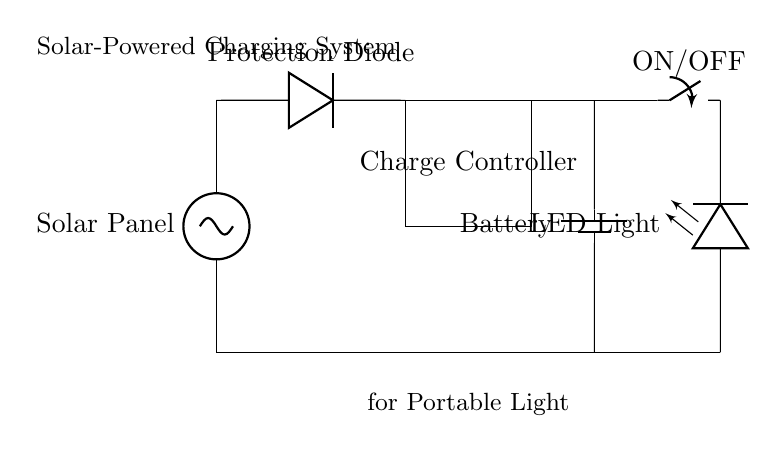What is the main component that generates electricity? The solar panel is the main component because it converts sunlight into electrical energy. You can see it at the top of the circuit diagram, marked as "Solar Panel".
Answer: Solar Panel What component protects the circuit from reverse current? The protection diode prevents reverse current from damaging the solar panel and battery. It's indicated in the diagram right after the solar panel.
Answer: Protection Diode What is the function of the Charge Controller? The Charge Controller regulates the voltage and current from the solar panel to the battery, ensuring it is charged properly. You can see it in the rectangle labeled "Charge Controller".
Answer: Regulates charge How is the LED Light powered? The LED Light is powered by the battery, which stores the energy generated by the solar panel. The connections shown in the diagram indicate that the battery delivers power to the LED light, especially when the switch is on.
Answer: Through the Battery What happens when the switch is turned on? When the switch is turned on, it completes the circuit, allowing electricity to flow from the battery to the LED light, lighting it up. This is indicated by the connection in the diagram.
Answer: LED lights up How does sunlight affect the overall system? Sunlight is essential as it allows the solar panel to generate electricity. Without sunlight, the solar panel cannot produce power, impacting the charging of the battery and operation of the LED light.
Answer: Generates electricity 